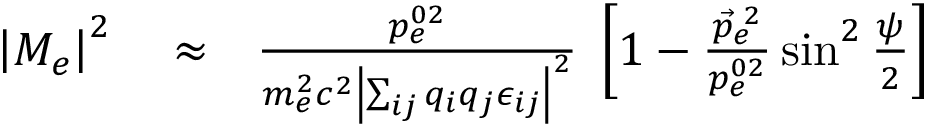Convert formula to latex. <formula><loc_0><loc_0><loc_500><loc_500>\begin{array} { r l r } { \left | M _ { e } \right | ^ { 2 } } & \approx } & { \frac { p _ { e } ^ { 0 2 } } { m _ { e } ^ { 2 } c ^ { 2 } \left | \sum _ { i j } q _ { i } q _ { j } \epsilon _ { i j } \right | ^ { 2 } } \, \left [ 1 - \frac { \vec { p } _ { e } ^ { \, 2 } } { p _ { e } ^ { 0 2 } } \sin ^ { 2 } \frac { \psi } { 2 } \right ] } \end{array}</formula> 